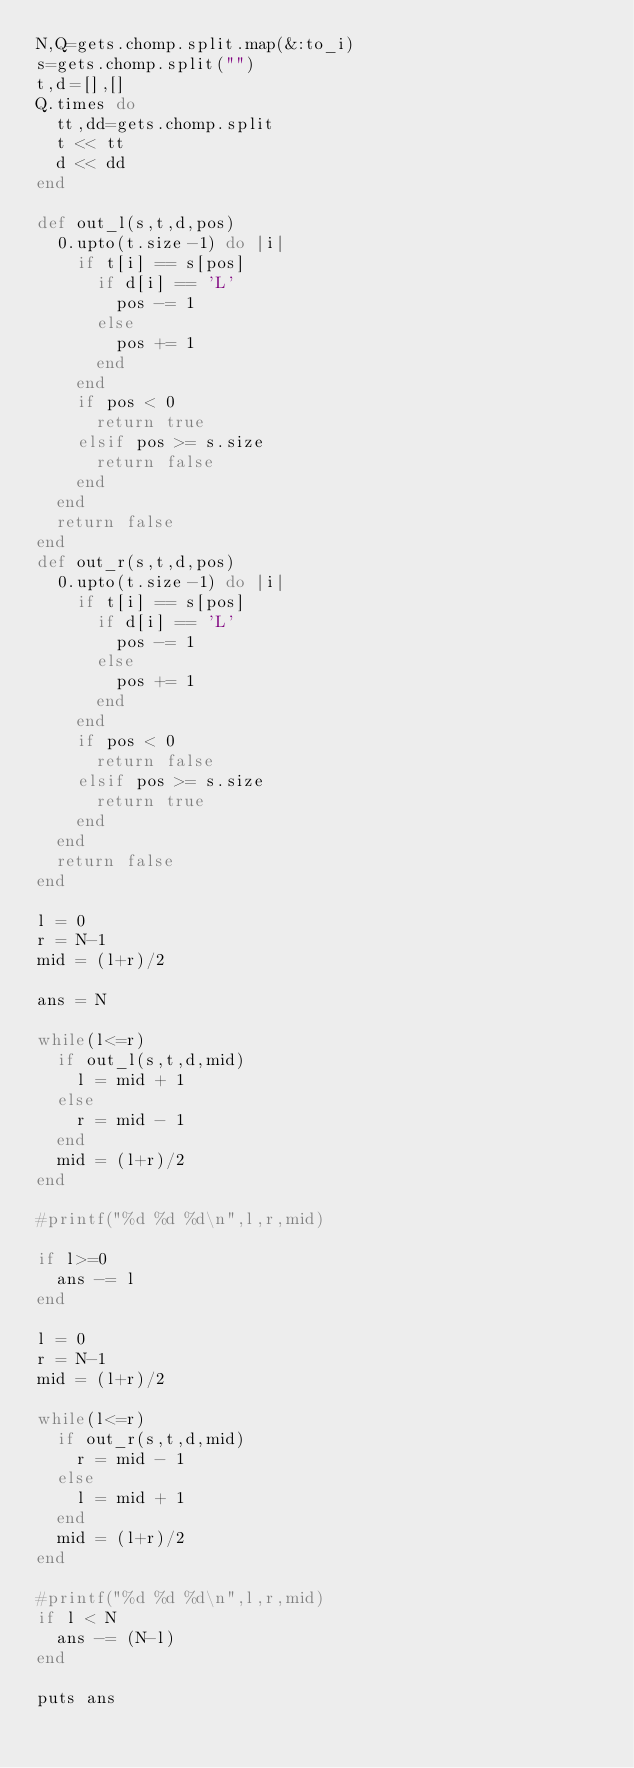Convert code to text. <code><loc_0><loc_0><loc_500><loc_500><_Ruby_>N,Q=gets.chomp.split.map(&:to_i)
s=gets.chomp.split("")
t,d=[],[]
Q.times do
  tt,dd=gets.chomp.split
  t << tt
  d << dd
end

def out_l(s,t,d,pos)
  0.upto(t.size-1) do |i|
    if t[i] == s[pos]
      if d[i] == 'L'
        pos -= 1
      else
        pos += 1
      end
    end
    if pos < 0
      return true
    elsif pos >= s.size
      return false
    end
  end
  return false
end
def out_r(s,t,d,pos)
  0.upto(t.size-1) do |i|
    if t[i] == s[pos]
      if d[i] == 'L'
        pos -= 1
      else
        pos += 1
      end
    end
    if pos < 0
      return false
    elsif pos >= s.size
      return true
    end
  end
  return false
end

l = 0
r = N-1
mid = (l+r)/2

ans = N

while(l<=r)
  if out_l(s,t,d,mid)
    l = mid + 1
  else
    r = mid - 1
  end
  mid = (l+r)/2
end

#printf("%d %d %d\n",l,r,mid)

if l>=0
  ans -= l
end

l = 0
r = N-1
mid = (l+r)/2

while(l<=r)
  if out_r(s,t,d,mid)
    r = mid - 1
  else
    l = mid + 1
  end
  mid = (l+r)/2
end

#printf("%d %d %d\n",l,r,mid)
if l < N
  ans -= (N-l)
end

puts ans

</code> 